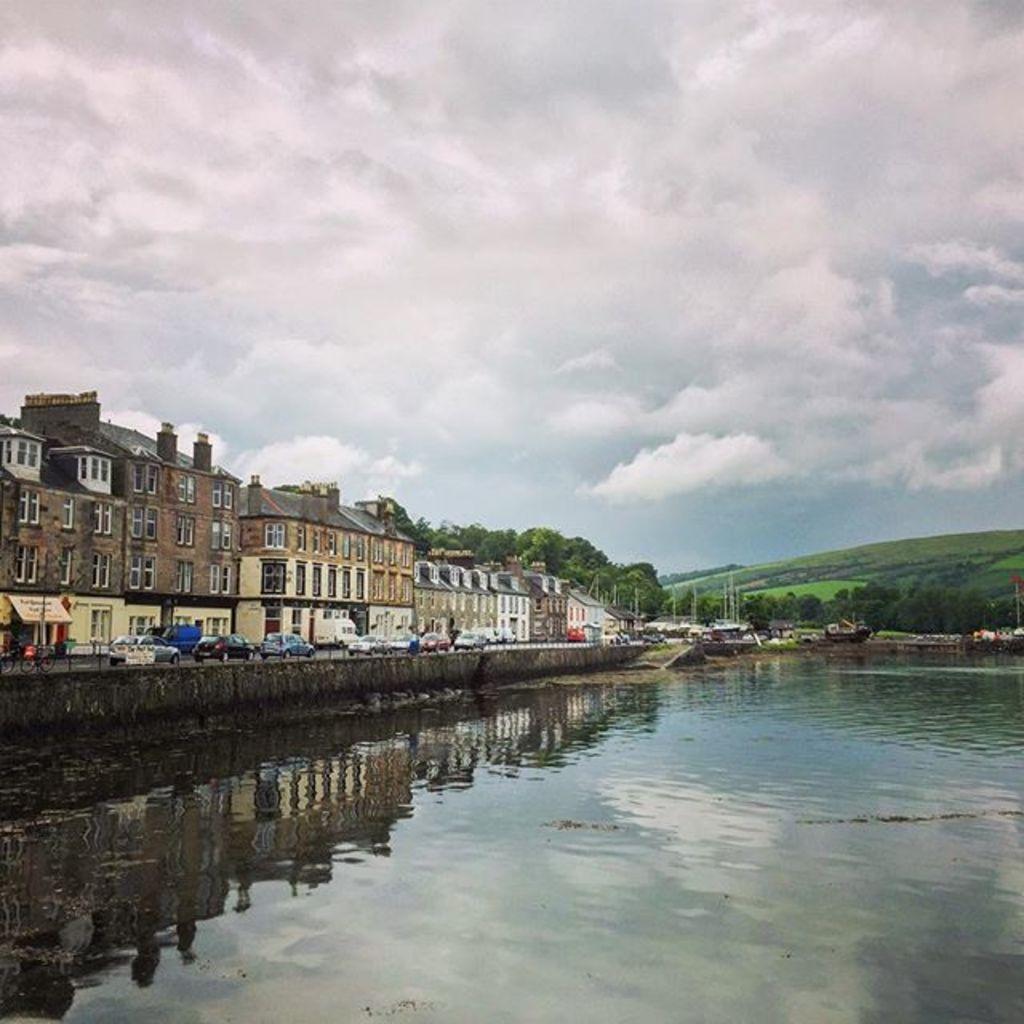In one or two sentences, can you explain what this image depicts? In this picture we can observe a lake. There are some cars on the road. We can observe some buildings. In the background there are trees and a hill. We can observe a sky with some clouds. 